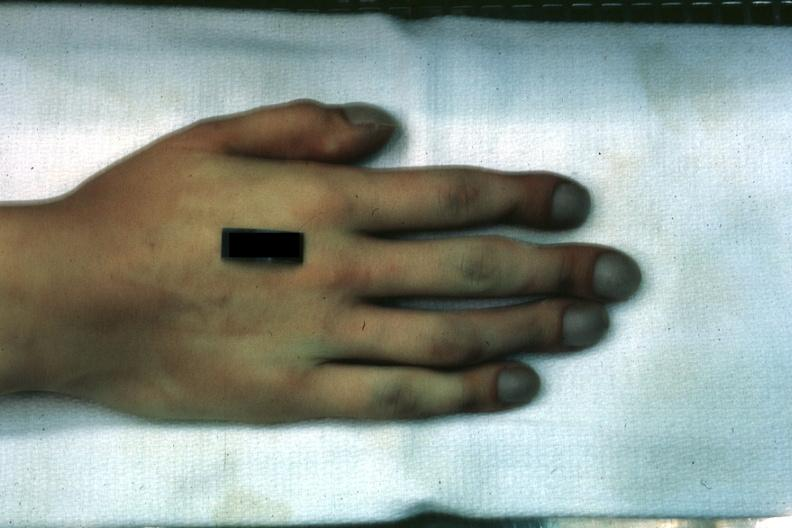s hand present?
Answer the question using a single word or phrase. Yes 